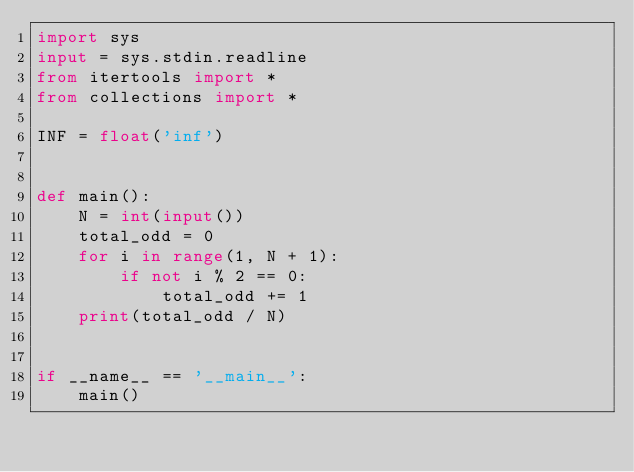<code> <loc_0><loc_0><loc_500><loc_500><_Python_>import sys
input = sys.stdin.readline
from itertools import *
from collections import *

INF = float('inf')


def main():
    N = int(input())
    total_odd = 0
    for i in range(1, N + 1):
        if not i % 2 == 0:
            total_odd += 1
    print(total_odd / N)


if __name__ == '__main__':
    main()
</code> 